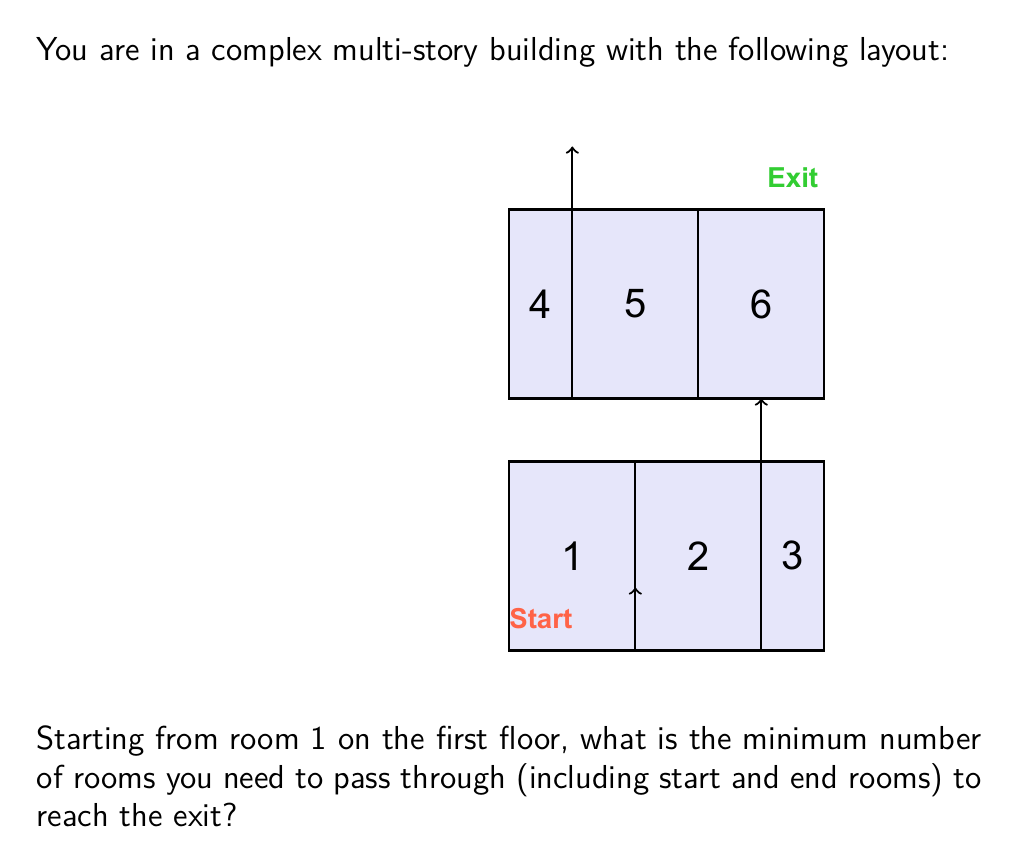Give your solution to this math problem. Let's analyze this problem step-by-step:

1) We start in room 1 on the first floor.

2) To reach the exit, we need to get to the second floor and then to room 6.

3) The possible paths are:

   Path 1: 1 → 2 → 3 → 5 → 6
   Path 2: 1 → 2 → 5 → 6

4) Let's count the rooms for each path:

   Path 1: 5 rooms (1, 2, 3, 5, 6)
   Path 2: 4 rooms (1, 2, 5, 6)

5) The question asks for the minimum number of rooms, so we choose Path 2.

Therefore, the minimum number of rooms to pass through is 4.
Answer: 4 